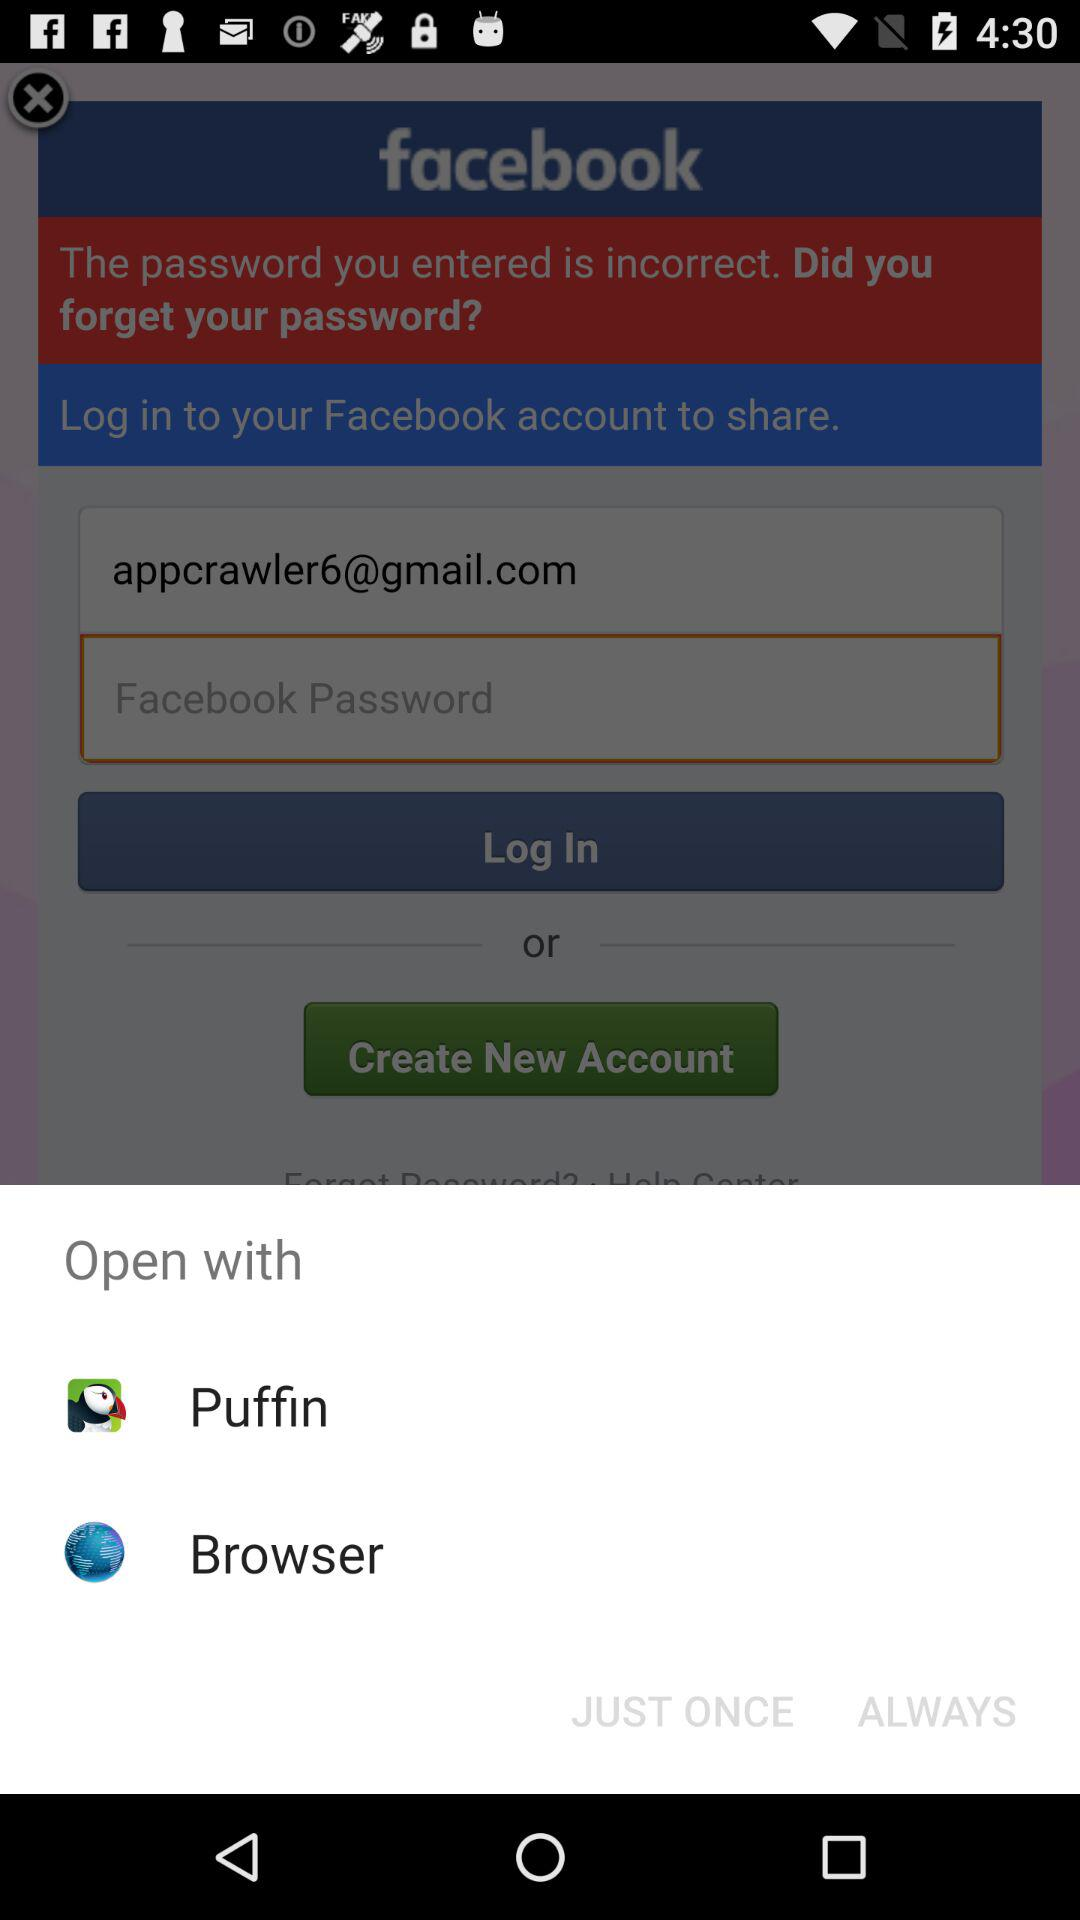How many characters are required for the password?
When the provided information is insufficient, respond with <no answer>. <no answer> 